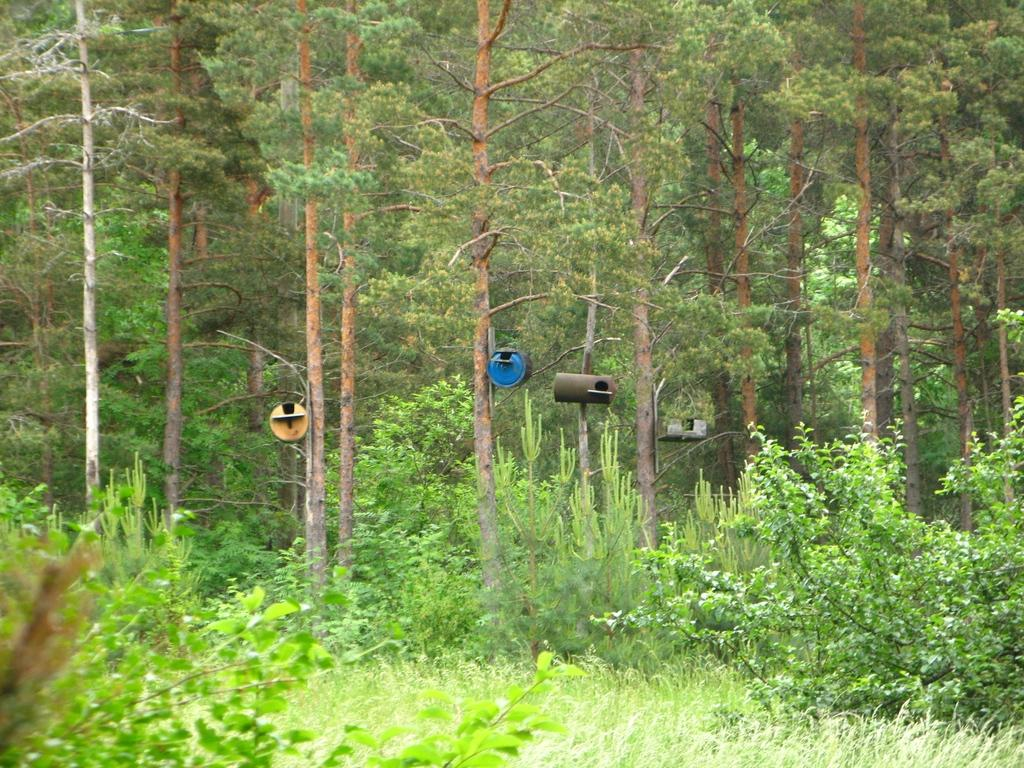What type of vegetation can be seen in the image? There are trees, plants, and grass in the image. What is attached to the trees in the image? There are machines attached to the trees in the image. Can you see a snake playing a guitar in the image? No, there is no snake or guitar present in the image. Is there a chess game being played in the image? No, there is no chess game or any indication of a game being played in the image. 